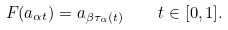<formula> <loc_0><loc_0><loc_500><loc_500>F ( a _ { \alpha t } ) = a _ { \beta \tau _ { \alpha } ( t ) } \quad t \in [ 0 , 1 ] .</formula> 